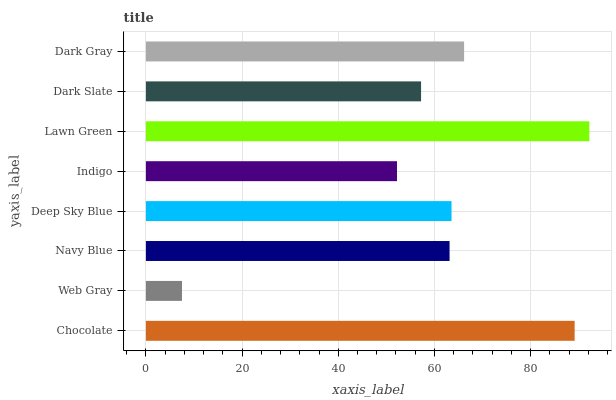Is Web Gray the minimum?
Answer yes or no. Yes. Is Lawn Green the maximum?
Answer yes or no. Yes. Is Navy Blue the minimum?
Answer yes or no. No. Is Navy Blue the maximum?
Answer yes or no. No. Is Navy Blue greater than Web Gray?
Answer yes or no. Yes. Is Web Gray less than Navy Blue?
Answer yes or no. Yes. Is Web Gray greater than Navy Blue?
Answer yes or no. No. Is Navy Blue less than Web Gray?
Answer yes or no. No. Is Deep Sky Blue the high median?
Answer yes or no. Yes. Is Navy Blue the low median?
Answer yes or no. Yes. Is Chocolate the high median?
Answer yes or no. No. Is Web Gray the low median?
Answer yes or no. No. 